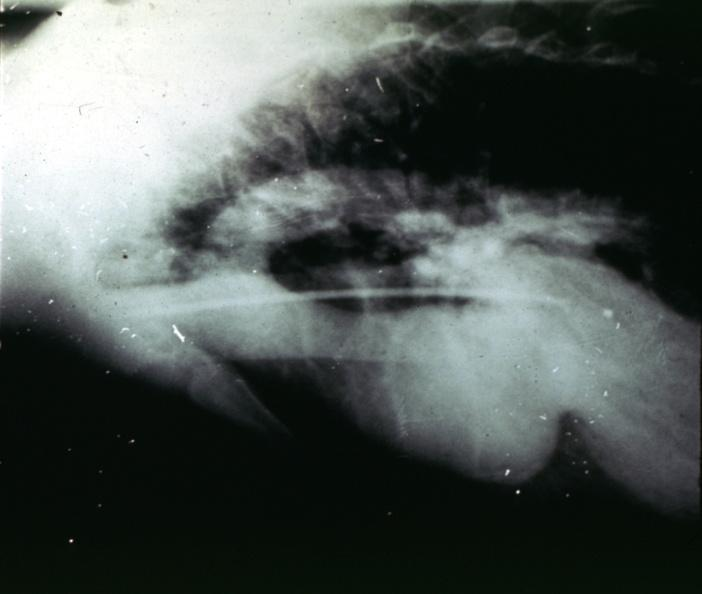s intraductal lesions present?
Answer the question using a single word or phrase. No 